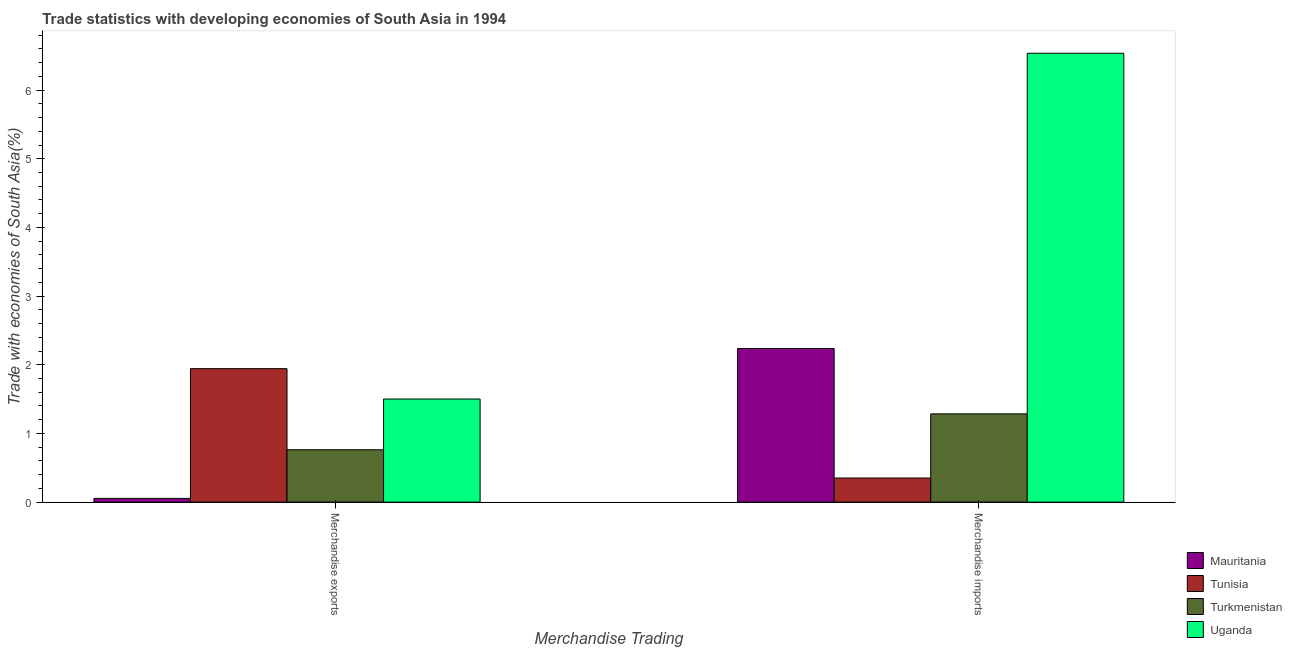How many different coloured bars are there?
Your response must be concise. 4. How many groups of bars are there?
Your answer should be compact. 2. Are the number of bars on each tick of the X-axis equal?
Provide a short and direct response. Yes. How many bars are there on the 2nd tick from the left?
Provide a succinct answer. 4. How many bars are there on the 1st tick from the right?
Provide a short and direct response. 4. What is the label of the 2nd group of bars from the left?
Offer a very short reply. Merchandise imports. What is the merchandise exports in Uganda?
Your response must be concise. 1.5. Across all countries, what is the maximum merchandise imports?
Your response must be concise. 6.54. Across all countries, what is the minimum merchandise imports?
Offer a terse response. 0.35. In which country was the merchandise imports maximum?
Provide a short and direct response. Uganda. In which country was the merchandise exports minimum?
Make the answer very short. Mauritania. What is the total merchandise exports in the graph?
Ensure brevity in your answer.  4.26. What is the difference between the merchandise imports in Uganda and that in Turkmenistan?
Ensure brevity in your answer.  5.25. What is the difference between the merchandise imports in Uganda and the merchandise exports in Turkmenistan?
Provide a succinct answer. 5.77. What is the average merchandise exports per country?
Your answer should be very brief. 1.07. What is the difference between the merchandise exports and merchandise imports in Uganda?
Your response must be concise. -5.03. What is the ratio of the merchandise exports in Turkmenistan to that in Mauritania?
Your response must be concise. 14.11. In how many countries, is the merchandise exports greater than the average merchandise exports taken over all countries?
Your response must be concise. 2. What does the 4th bar from the left in Merchandise exports represents?
Offer a terse response. Uganda. What does the 2nd bar from the right in Merchandise exports represents?
Offer a very short reply. Turkmenistan. What is the difference between two consecutive major ticks on the Y-axis?
Give a very brief answer. 1. Are the values on the major ticks of Y-axis written in scientific E-notation?
Your answer should be very brief. No. Does the graph contain any zero values?
Make the answer very short. No. What is the title of the graph?
Your answer should be very brief. Trade statistics with developing economies of South Asia in 1994. What is the label or title of the X-axis?
Make the answer very short. Merchandise Trading. What is the label or title of the Y-axis?
Offer a very short reply. Trade with economies of South Asia(%). What is the Trade with economies of South Asia(%) in Mauritania in Merchandise exports?
Make the answer very short. 0.05. What is the Trade with economies of South Asia(%) in Tunisia in Merchandise exports?
Provide a succinct answer. 1.94. What is the Trade with economies of South Asia(%) in Turkmenistan in Merchandise exports?
Provide a short and direct response. 0.76. What is the Trade with economies of South Asia(%) of Uganda in Merchandise exports?
Ensure brevity in your answer.  1.5. What is the Trade with economies of South Asia(%) of Mauritania in Merchandise imports?
Offer a terse response. 2.24. What is the Trade with economies of South Asia(%) of Tunisia in Merchandise imports?
Your answer should be very brief. 0.35. What is the Trade with economies of South Asia(%) in Turkmenistan in Merchandise imports?
Make the answer very short. 1.29. What is the Trade with economies of South Asia(%) in Uganda in Merchandise imports?
Provide a succinct answer. 6.54. Across all Merchandise Trading, what is the maximum Trade with economies of South Asia(%) in Mauritania?
Your answer should be compact. 2.24. Across all Merchandise Trading, what is the maximum Trade with economies of South Asia(%) of Tunisia?
Keep it short and to the point. 1.94. Across all Merchandise Trading, what is the maximum Trade with economies of South Asia(%) in Turkmenistan?
Your answer should be compact. 1.29. Across all Merchandise Trading, what is the maximum Trade with economies of South Asia(%) in Uganda?
Give a very brief answer. 6.54. Across all Merchandise Trading, what is the minimum Trade with economies of South Asia(%) in Mauritania?
Provide a succinct answer. 0.05. Across all Merchandise Trading, what is the minimum Trade with economies of South Asia(%) of Tunisia?
Your response must be concise. 0.35. Across all Merchandise Trading, what is the minimum Trade with economies of South Asia(%) in Turkmenistan?
Your response must be concise. 0.76. Across all Merchandise Trading, what is the minimum Trade with economies of South Asia(%) of Uganda?
Make the answer very short. 1.5. What is the total Trade with economies of South Asia(%) of Mauritania in the graph?
Provide a short and direct response. 2.29. What is the total Trade with economies of South Asia(%) in Tunisia in the graph?
Provide a succinct answer. 2.29. What is the total Trade with economies of South Asia(%) of Turkmenistan in the graph?
Your answer should be compact. 2.05. What is the total Trade with economies of South Asia(%) of Uganda in the graph?
Your response must be concise. 8.04. What is the difference between the Trade with economies of South Asia(%) of Mauritania in Merchandise exports and that in Merchandise imports?
Provide a succinct answer. -2.18. What is the difference between the Trade with economies of South Asia(%) of Tunisia in Merchandise exports and that in Merchandise imports?
Your answer should be compact. 1.59. What is the difference between the Trade with economies of South Asia(%) in Turkmenistan in Merchandise exports and that in Merchandise imports?
Ensure brevity in your answer.  -0.52. What is the difference between the Trade with economies of South Asia(%) of Uganda in Merchandise exports and that in Merchandise imports?
Your answer should be compact. -5.03. What is the difference between the Trade with economies of South Asia(%) in Mauritania in Merchandise exports and the Trade with economies of South Asia(%) in Tunisia in Merchandise imports?
Provide a short and direct response. -0.3. What is the difference between the Trade with economies of South Asia(%) of Mauritania in Merchandise exports and the Trade with economies of South Asia(%) of Turkmenistan in Merchandise imports?
Ensure brevity in your answer.  -1.23. What is the difference between the Trade with economies of South Asia(%) of Mauritania in Merchandise exports and the Trade with economies of South Asia(%) of Uganda in Merchandise imports?
Provide a short and direct response. -6.48. What is the difference between the Trade with economies of South Asia(%) of Tunisia in Merchandise exports and the Trade with economies of South Asia(%) of Turkmenistan in Merchandise imports?
Your response must be concise. 0.66. What is the difference between the Trade with economies of South Asia(%) in Tunisia in Merchandise exports and the Trade with economies of South Asia(%) in Uganda in Merchandise imports?
Provide a succinct answer. -4.59. What is the difference between the Trade with economies of South Asia(%) of Turkmenistan in Merchandise exports and the Trade with economies of South Asia(%) of Uganda in Merchandise imports?
Your response must be concise. -5.77. What is the average Trade with economies of South Asia(%) in Mauritania per Merchandise Trading?
Your answer should be very brief. 1.15. What is the average Trade with economies of South Asia(%) of Tunisia per Merchandise Trading?
Your answer should be very brief. 1.15. What is the average Trade with economies of South Asia(%) of Turkmenistan per Merchandise Trading?
Keep it short and to the point. 1.02. What is the average Trade with economies of South Asia(%) in Uganda per Merchandise Trading?
Your answer should be very brief. 4.02. What is the difference between the Trade with economies of South Asia(%) of Mauritania and Trade with economies of South Asia(%) of Tunisia in Merchandise exports?
Provide a short and direct response. -1.89. What is the difference between the Trade with economies of South Asia(%) of Mauritania and Trade with economies of South Asia(%) of Turkmenistan in Merchandise exports?
Provide a short and direct response. -0.71. What is the difference between the Trade with economies of South Asia(%) in Mauritania and Trade with economies of South Asia(%) in Uganda in Merchandise exports?
Provide a succinct answer. -1.45. What is the difference between the Trade with economies of South Asia(%) of Tunisia and Trade with economies of South Asia(%) of Turkmenistan in Merchandise exports?
Offer a very short reply. 1.18. What is the difference between the Trade with economies of South Asia(%) in Tunisia and Trade with economies of South Asia(%) in Uganda in Merchandise exports?
Offer a very short reply. 0.44. What is the difference between the Trade with economies of South Asia(%) in Turkmenistan and Trade with economies of South Asia(%) in Uganda in Merchandise exports?
Your response must be concise. -0.74. What is the difference between the Trade with economies of South Asia(%) in Mauritania and Trade with economies of South Asia(%) in Tunisia in Merchandise imports?
Give a very brief answer. 1.89. What is the difference between the Trade with economies of South Asia(%) in Mauritania and Trade with economies of South Asia(%) in Turkmenistan in Merchandise imports?
Keep it short and to the point. 0.95. What is the difference between the Trade with economies of South Asia(%) in Mauritania and Trade with economies of South Asia(%) in Uganda in Merchandise imports?
Give a very brief answer. -4.3. What is the difference between the Trade with economies of South Asia(%) in Tunisia and Trade with economies of South Asia(%) in Turkmenistan in Merchandise imports?
Keep it short and to the point. -0.93. What is the difference between the Trade with economies of South Asia(%) in Tunisia and Trade with economies of South Asia(%) in Uganda in Merchandise imports?
Your answer should be very brief. -6.18. What is the difference between the Trade with economies of South Asia(%) in Turkmenistan and Trade with economies of South Asia(%) in Uganda in Merchandise imports?
Give a very brief answer. -5.25. What is the ratio of the Trade with economies of South Asia(%) of Mauritania in Merchandise exports to that in Merchandise imports?
Make the answer very short. 0.02. What is the ratio of the Trade with economies of South Asia(%) of Tunisia in Merchandise exports to that in Merchandise imports?
Your answer should be compact. 5.54. What is the ratio of the Trade with economies of South Asia(%) of Turkmenistan in Merchandise exports to that in Merchandise imports?
Provide a succinct answer. 0.59. What is the ratio of the Trade with economies of South Asia(%) of Uganda in Merchandise exports to that in Merchandise imports?
Your answer should be very brief. 0.23. What is the difference between the highest and the second highest Trade with economies of South Asia(%) in Mauritania?
Offer a very short reply. 2.18. What is the difference between the highest and the second highest Trade with economies of South Asia(%) of Tunisia?
Provide a short and direct response. 1.59. What is the difference between the highest and the second highest Trade with economies of South Asia(%) in Turkmenistan?
Offer a terse response. 0.52. What is the difference between the highest and the second highest Trade with economies of South Asia(%) of Uganda?
Keep it short and to the point. 5.03. What is the difference between the highest and the lowest Trade with economies of South Asia(%) in Mauritania?
Offer a very short reply. 2.18. What is the difference between the highest and the lowest Trade with economies of South Asia(%) of Tunisia?
Your response must be concise. 1.59. What is the difference between the highest and the lowest Trade with economies of South Asia(%) in Turkmenistan?
Keep it short and to the point. 0.52. What is the difference between the highest and the lowest Trade with economies of South Asia(%) of Uganda?
Keep it short and to the point. 5.03. 